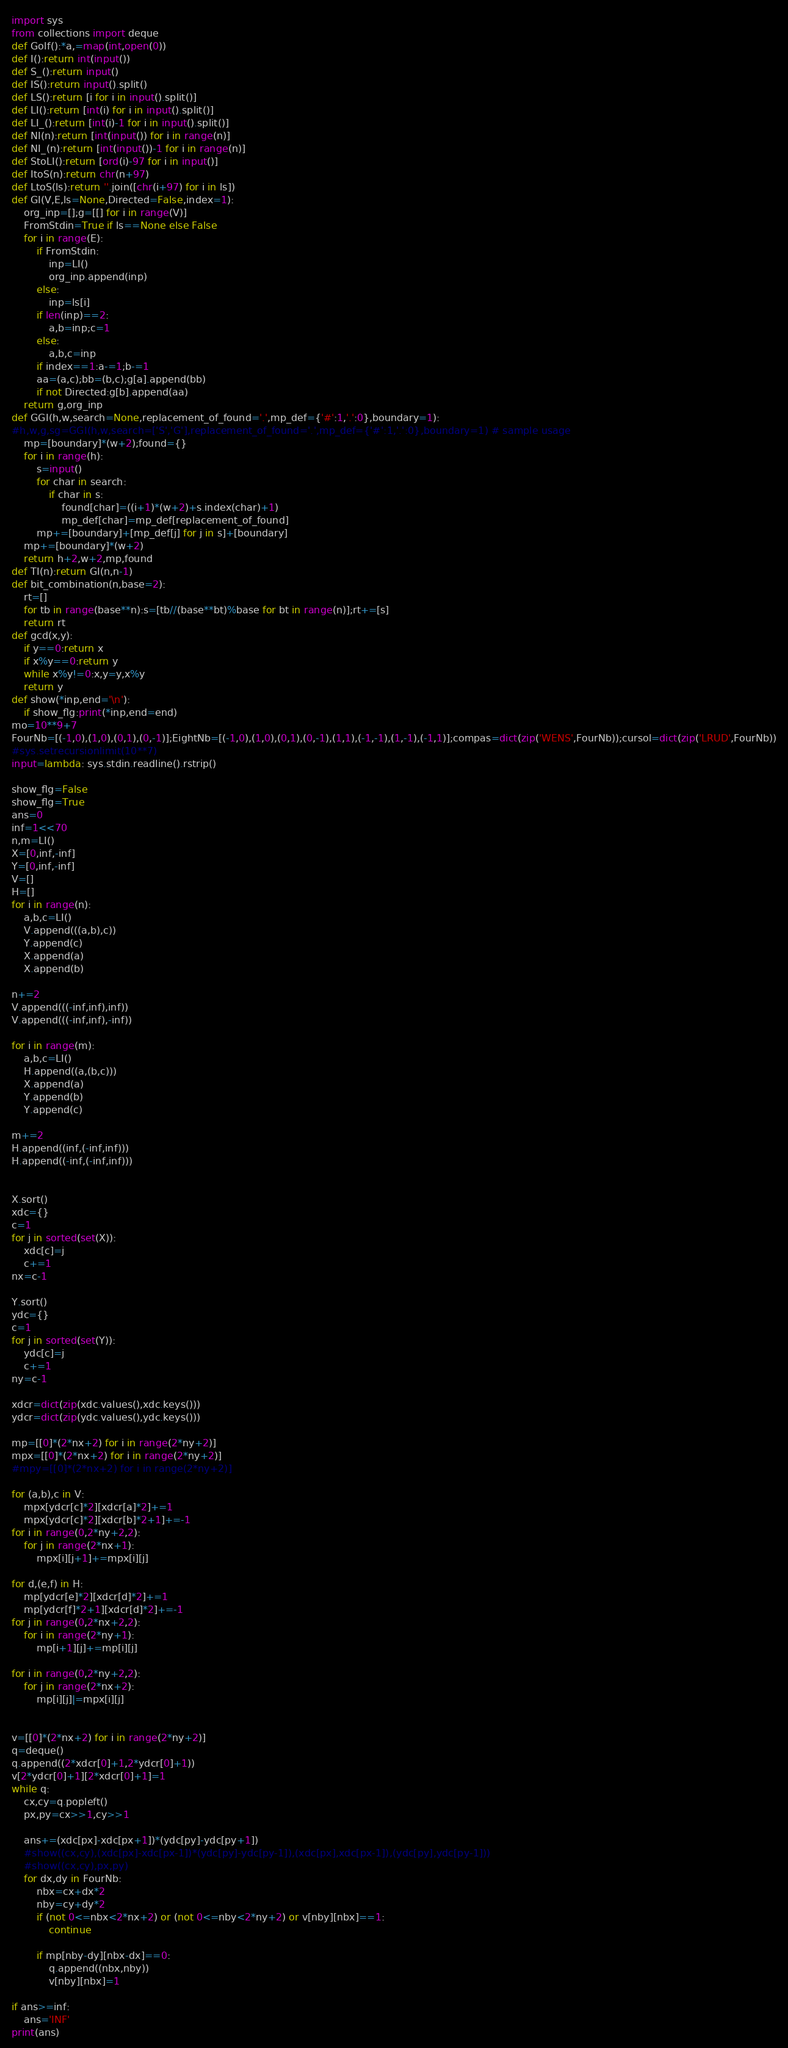<code> <loc_0><loc_0><loc_500><loc_500><_Python_>import sys
from collections import deque
def Golf():*a,=map(int,open(0))
def I():return int(input())
def S_():return input()
def IS():return input().split()
def LS():return [i for i in input().split()]
def LI():return [int(i) for i in input().split()]
def LI_():return [int(i)-1 for i in input().split()]
def NI(n):return [int(input()) for i in range(n)]
def NI_(n):return [int(input())-1 for i in range(n)]
def StoLI():return [ord(i)-97 for i in input()]
def ItoS(n):return chr(n+97)
def LtoS(ls):return ''.join([chr(i+97) for i in ls])
def GI(V,E,ls=None,Directed=False,index=1):
    org_inp=[];g=[[] for i in range(V)]
    FromStdin=True if ls==None else False
    for i in range(E):
        if FromStdin:
            inp=LI()
            org_inp.append(inp)
        else:
            inp=ls[i]
        if len(inp)==2:
            a,b=inp;c=1
        else:
            a,b,c=inp
        if index==1:a-=1;b-=1
        aa=(a,c);bb=(b,c);g[a].append(bb)
        if not Directed:g[b].append(aa)
    return g,org_inp
def GGI(h,w,search=None,replacement_of_found='.',mp_def={'#':1,'.':0},boundary=1):
#h,w,g,sg=GGI(h,w,search=['S','G'],replacement_of_found='.',mp_def={'#':1,'.':0},boundary=1) # sample usage
    mp=[boundary]*(w+2);found={}
    for i in range(h):
        s=input()
        for char in search:
            if char in s:
                found[char]=((i+1)*(w+2)+s.index(char)+1)
                mp_def[char]=mp_def[replacement_of_found]
        mp+=[boundary]+[mp_def[j] for j in s]+[boundary]
    mp+=[boundary]*(w+2)
    return h+2,w+2,mp,found
def TI(n):return GI(n,n-1)
def bit_combination(n,base=2):
    rt=[]
    for tb in range(base**n):s=[tb//(base**bt)%base for bt in range(n)];rt+=[s]
    return rt
def gcd(x,y):
    if y==0:return x
    if x%y==0:return y
    while x%y!=0:x,y=y,x%y
    return y
def show(*inp,end='\n'):
    if show_flg:print(*inp,end=end)
mo=10**9+7
FourNb=[(-1,0),(1,0),(0,1),(0,-1)];EightNb=[(-1,0),(1,0),(0,1),(0,-1),(1,1),(-1,-1),(1,-1),(-1,1)];compas=dict(zip('WENS',FourNb));cursol=dict(zip('LRUD',FourNb))
#sys.setrecursionlimit(10**7)
input=lambda: sys.stdin.readline().rstrip()

show_flg=False
show_flg=True
ans=0
inf=1<<70
n,m=LI()
X=[0,inf,-inf]
Y=[0,inf,-inf]
V=[]
H=[]
for i in range(n):
    a,b,c=LI()
    V.append(((a,b),c))
    Y.append(c)
    X.append(a)
    X.append(b)

n+=2
V.append(((-inf,inf),inf))
V.append(((-inf,inf),-inf))

for i in range(m):
    a,b,c=LI()
    H.append((a,(b,c)))
    X.append(a)
    Y.append(b)
    Y.append(c)

m+=2
H.append((inf,(-inf,inf)))
H.append((-inf,(-inf,inf)))


X.sort()
xdc={}
c=1
for j in sorted(set(X)):
    xdc[c]=j
    c+=1
nx=c-1

Y.sort()
ydc={}
c=1
for j in sorted(set(Y)):
    ydc[c]=j
    c+=1
ny=c-1

xdcr=dict(zip(xdc.values(),xdc.keys()))
ydcr=dict(zip(ydc.values(),ydc.keys()))

mp=[[0]*(2*nx+2) for i in range(2*ny+2)]
mpx=[[0]*(2*nx+2) for i in range(2*ny+2)]
#mpy=[[0]*(2*nx+2) for i in range(2*ny+2)]

for (a,b),c in V:
    mpx[ydcr[c]*2][xdcr[a]*2]+=1
    mpx[ydcr[c]*2][xdcr[b]*2+1]+=-1
for i in range(0,2*ny+2,2):
    for j in range(2*nx+1):
        mpx[i][j+1]+=mpx[i][j]
        
for d,(e,f) in H:
    mp[ydcr[e]*2][xdcr[d]*2]+=1
    mp[ydcr[f]*2+1][xdcr[d]*2]+=-1
for j in range(0,2*nx+2,2):
    for i in range(2*ny+1):
        mp[i+1][j]+=mp[i][j]

for i in range(0,2*ny+2,2):
    for j in range(2*nx+2):
        mp[i][j]|=mpx[i][j]


v=[[0]*(2*nx+2) for i in range(2*ny+2)]
q=deque()
q.append((2*xdcr[0]+1,2*ydcr[0]+1))
v[2*ydcr[0]+1][2*xdcr[0]+1]=1
while q:
    cx,cy=q.popleft()
    px,py=cx>>1,cy>>1
    
    ans+=(xdc[px]-xdc[px+1])*(ydc[py]-ydc[py+1])
    #show((cx,cy),(xdc[px]-xdc[px-1])*(ydc[py]-ydc[py-1]),(xdc[px],xdc[px-1]),(ydc[py],ydc[py-1]))
    #show((cx,cy),px,py)
    for dx,dy in FourNb:
        nbx=cx+dx*2
        nby=cy+dy*2
        if (not 0<=nbx<2*nx+2) or (not 0<=nby<2*ny+2) or v[nby][nbx]==1:
            continue
        
        if mp[nby-dy][nbx-dx]==0:
            q.append((nbx,nby))
            v[nby][nbx]=1

if ans>=inf:
    ans='INF'
print(ans)

</code> 